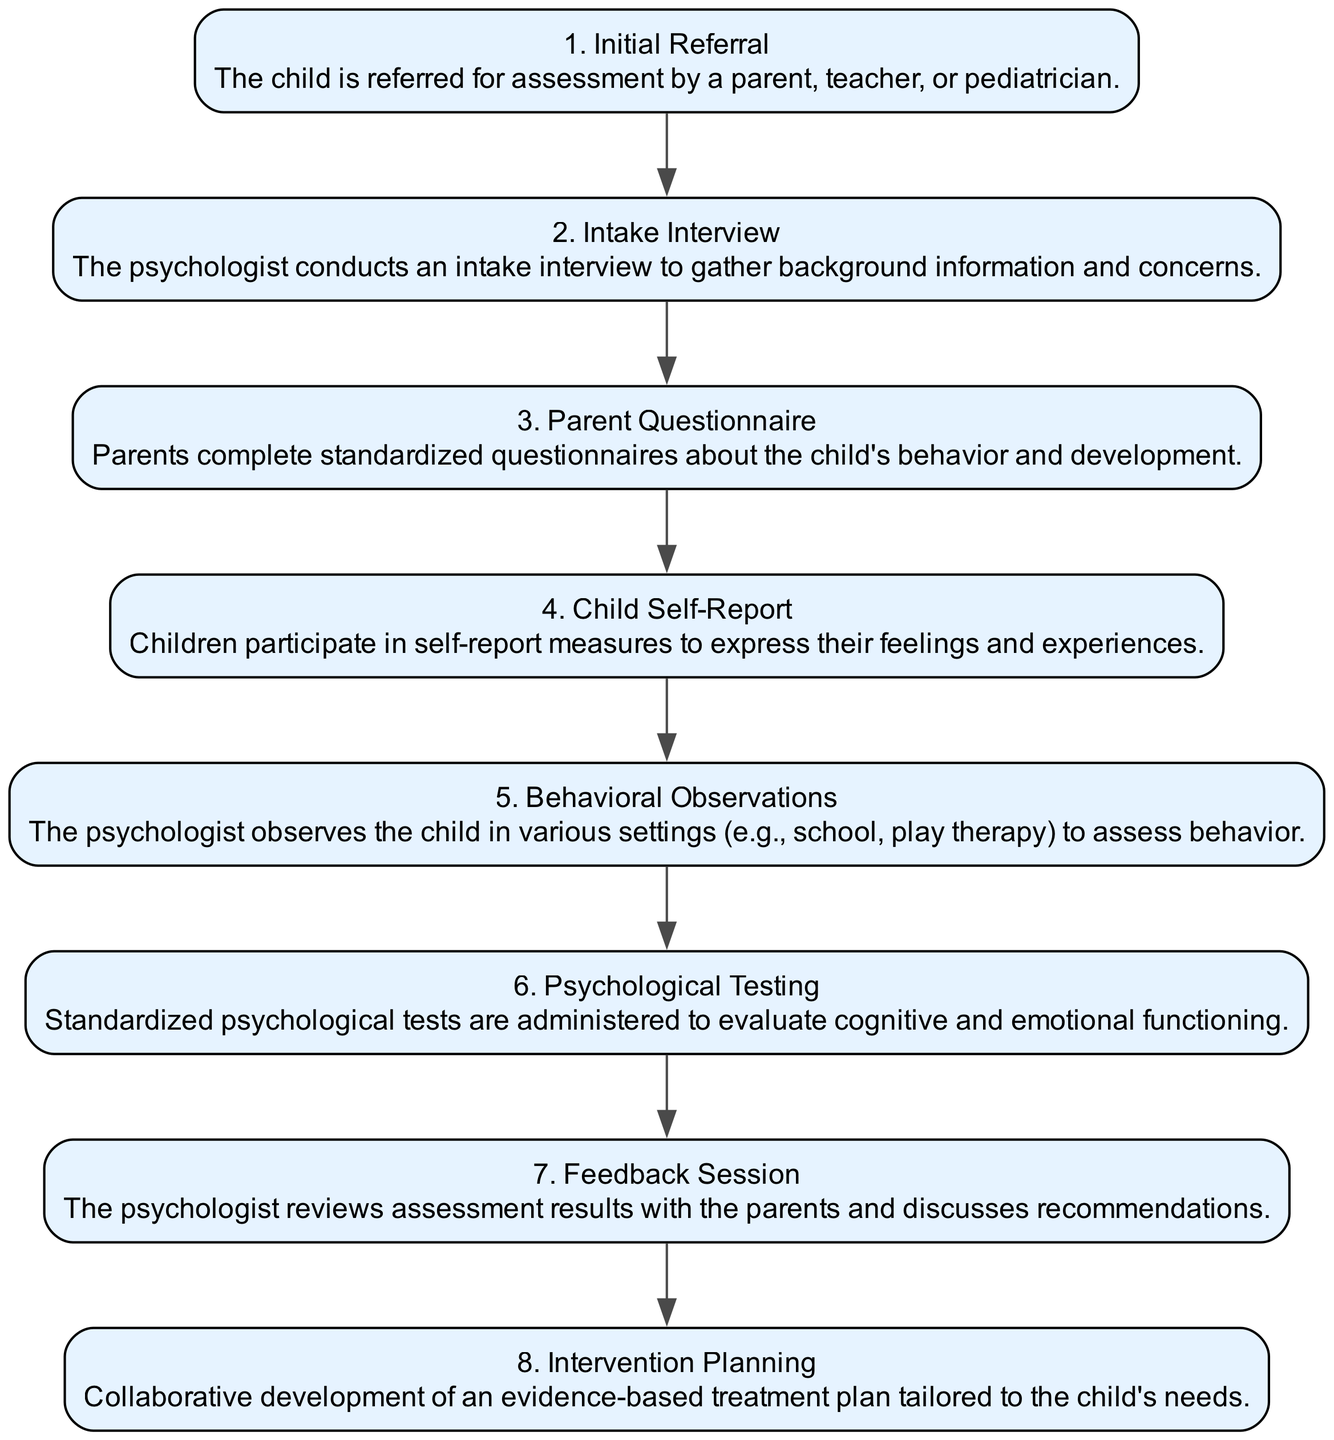What is the first step of the assessment process? The first step is "Initial Referral," as indicated at the beginning of the diagram, where a child is referred for assessment.
Answer: Initial Referral How many total steps are shown in the diagram? By counting the number of nodes in the diagram, there are eight distinct steps documented in the assessment process.
Answer: 8 What comes after the "Intake Interview"? The flow of the diagram shows that "Parent Questionnaire" directly follows the "Intake Interview," indicating the next action taken in the assessment process.
Answer: Parent Questionnaire Which step involves the child directly expressing their feelings? The step labeled "Child Self-Report" involves children participating in measures designed for them to express their feelings and experiences.
Answer: Child Self-Report What is the final action taken in the assessment process? The last step in the sequence is "Intervention Planning," which represents the concluding action after completing all assessment procedures.
Answer: Intervention Planning Explain the relationship between "Psychological Testing" and "Behavioral Observations." "Psychological Testing" follows "Behavioral Observations" in the sequence, indicating that behavioral observations might inform or be complemented by the standardized tests administered subsequently in the assessment.
Answer: Psychological Testing follows Behavioral Observations During which step are parents involved in completing questionnaires? The step titled "Parent Questionnaire" explicitly describes the involvement of parents in filling out standardized questionnaires about the child’s behavior and development.
Answer: Parent Questionnaire In which step does the psychologist provide feedback to the parents? The "Feedback Session" is where the psychologist reviews the results with the parents, allowing for discussion about the assessments conducted.
Answer: Feedback Session 